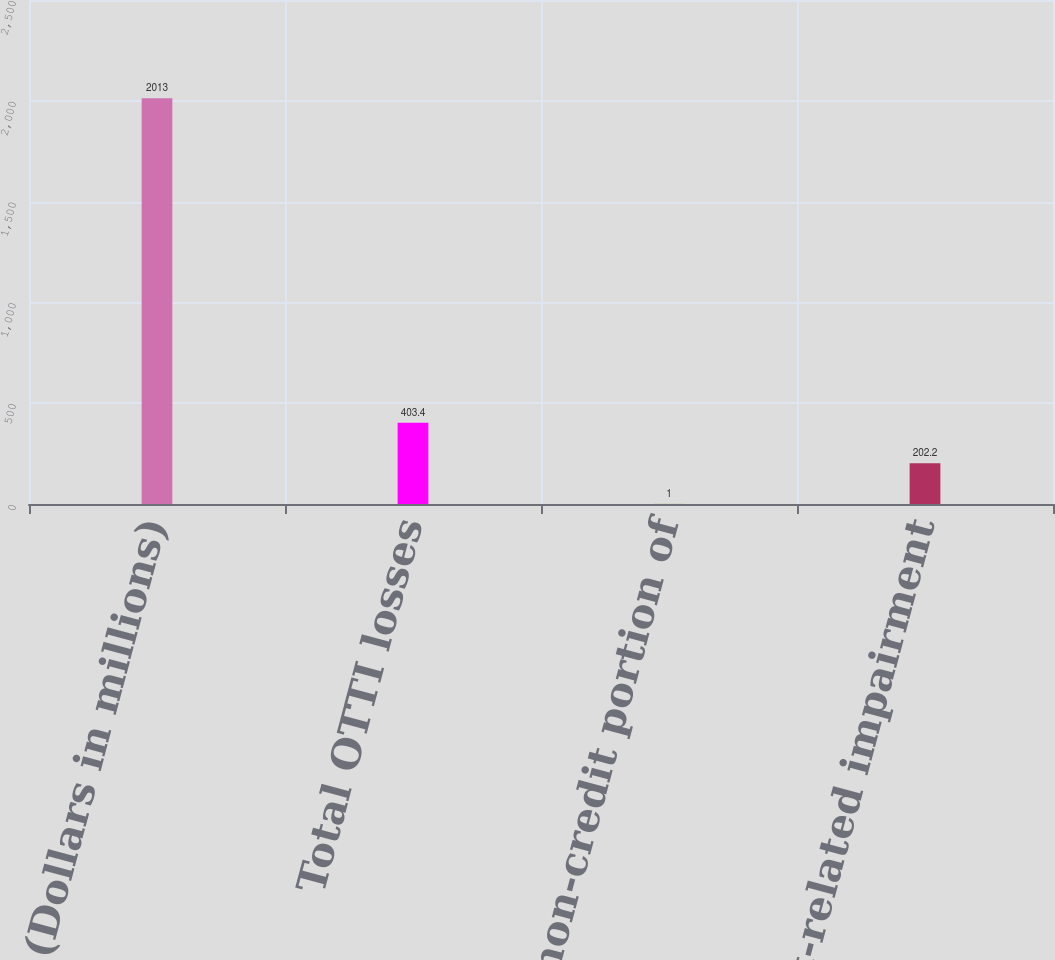Convert chart. <chart><loc_0><loc_0><loc_500><loc_500><bar_chart><fcel>(Dollars in millions)<fcel>Total OTTI losses<fcel>Less non-credit portion of<fcel>Net credit-related impairment<nl><fcel>2013<fcel>403.4<fcel>1<fcel>202.2<nl></chart> 